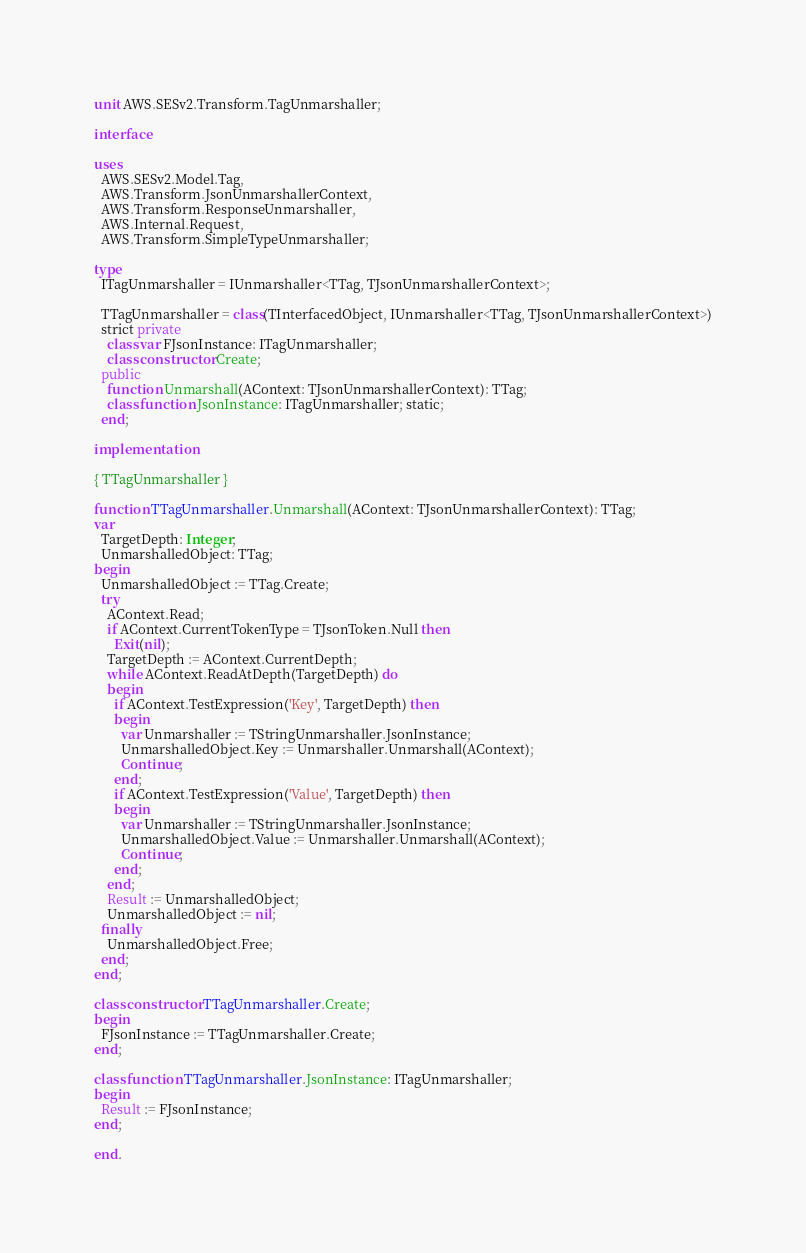Convert code to text. <code><loc_0><loc_0><loc_500><loc_500><_Pascal_>unit AWS.SESv2.Transform.TagUnmarshaller;

interface

uses
  AWS.SESv2.Model.Tag, 
  AWS.Transform.JsonUnmarshallerContext, 
  AWS.Transform.ResponseUnmarshaller, 
  AWS.Internal.Request, 
  AWS.Transform.SimpleTypeUnmarshaller;

type
  ITagUnmarshaller = IUnmarshaller<TTag, TJsonUnmarshallerContext>;
  
  TTagUnmarshaller = class(TInterfacedObject, IUnmarshaller<TTag, TJsonUnmarshallerContext>)
  strict private
    class var FJsonInstance: ITagUnmarshaller;
    class constructor Create;
  public
    function Unmarshall(AContext: TJsonUnmarshallerContext): TTag;
    class function JsonInstance: ITagUnmarshaller; static;
  end;
  
implementation

{ TTagUnmarshaller }

function TTagUnmarshaller.Unmarshall(AContext: TJsonUnmarshallerContext): TTag;
var
  TargetDepth: Integer;
  UnmarshalledObject: TTag;
begin
  UnmarshalledObject := TTag.Create;
  try
    AContext.Read;
    if AContext.CurrentTokenType = TJsonToken.Null then
      Exit(nil);
    TargetDepth := AContext.CurrentDepth;
    while AContext.ReadAtDepth(TargetDepth) do
    begin
      if AContext.TestExpression('Key', TargetDepth) then
      begin
        var Unmarshaller := TStringUnmarshaller.JsonInstance;
        UnmarshalledObject.Key := Unmarshaller.Unmarshall(AContext);
        Continue;
      end;
      if AContext.TestExpression('Value', TargetDepth) then
      begin
        var Unmarshaller := TStringUnmarshaller.JsonInstance;
        UnmarshalledObject.Value := Unmarshaller.Unmarshall(AContext);
        Continue;
      end;
    end;
    Result := UnmarshalledObject;
    UnmarshalledObject := nil;
  finally
    UnmarshalledObject.Free;
  end;
end;

class constructor TTagUnmarshaller.Create;
begin
  FJsonInstance := TTagUnmarshaller.Create;
end;

class function TTagUnmarshaller.JsonInstance: ITagUnmarshaller;
begin
  Result := FJsonInstance;
end;

end.
</code> 